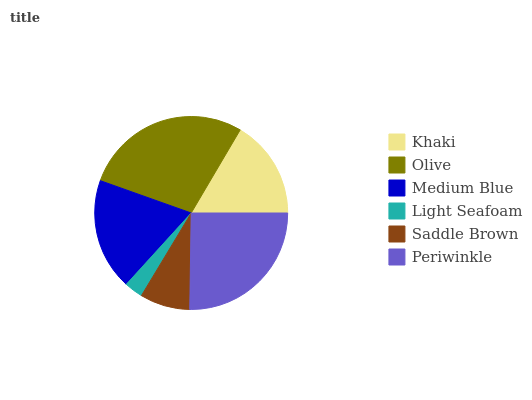Is Light Seafoam the minimum?
Answer yes or no. Yes. Is Olive the maximum?
Answer yes or no. Yes. Is Medium Blue the minimum?
Answer yes or no. No. Is Medium Blue the maximum?
Answer yes or no. No. Is Olive greater than Medium Blue?
Answer yes or no. Yes. Is Medium Blue less than Olive?
Answer yes or no. Yes. Is Medium Blue greater than Olive?
Answer yes or no. No. Is Olive less than Medium Blue?
Answer yes or no. No. Is Medium Blue the high median?
Answer yes or no. Yes. Is Khaki the low median?
Answer yes or no. Yes. Is Light Seafoam the high median?
Answer yes or no. No. Is Light Seafoam the low median?
Answer yes or no. No. 